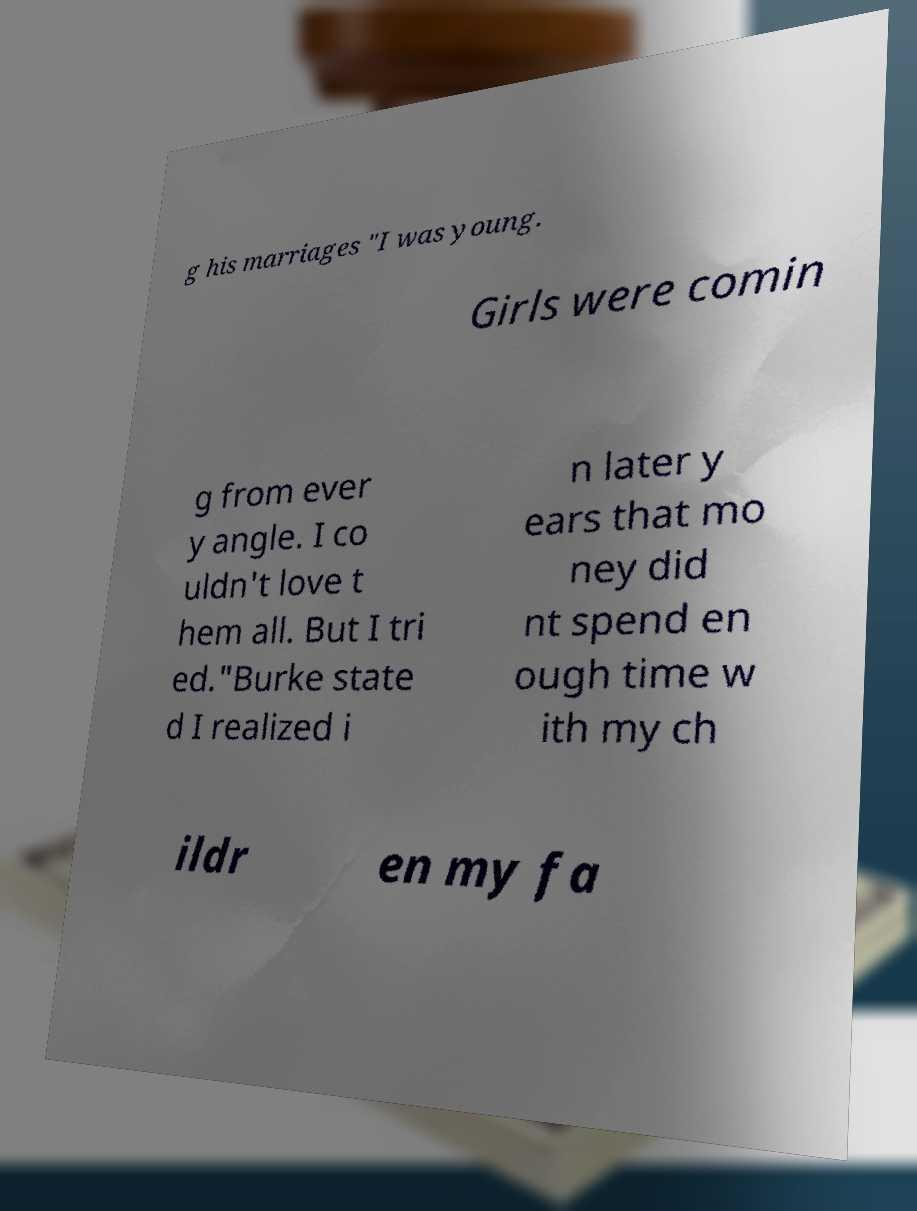I need the written content from this picture converted into text. Can you do that? g his marriages "I was young. Girls were comin g from ever y angle. I co uldn't love t hem all. But I tri ed."Burke state d I realized i n later y ears that mo ney did nt spend en ough time w ith my ch ildr en my fa 